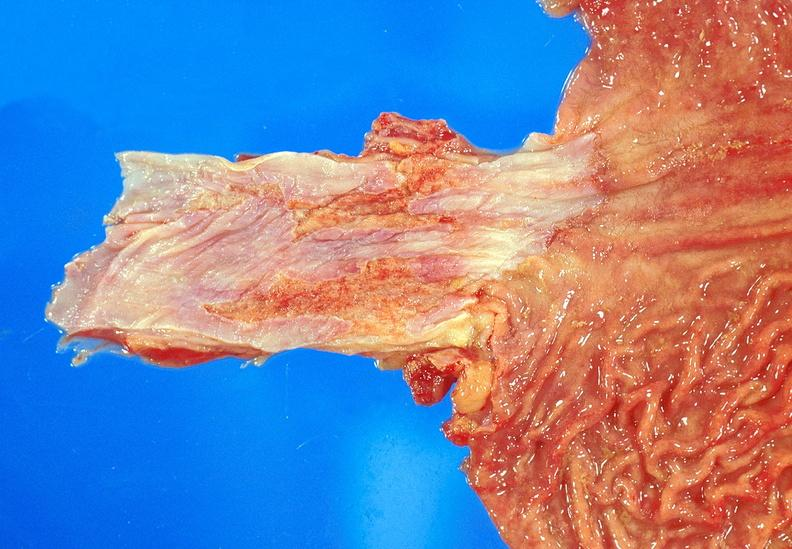what does this image show?
Answer the question using a single word or phrase. Barrett 's esophagus 